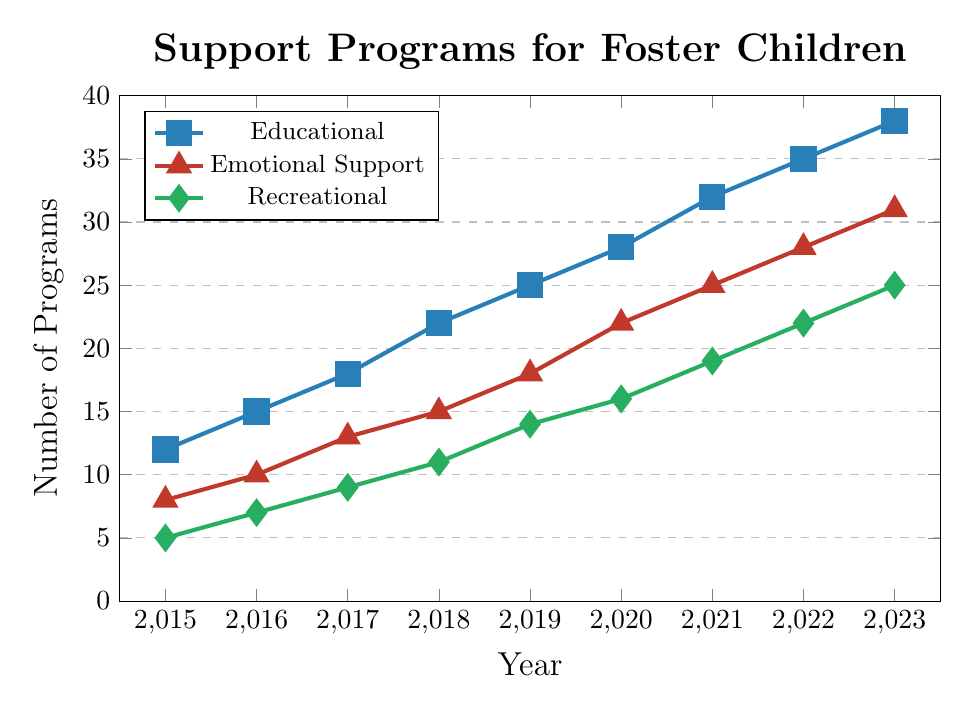What type of support programs had the highest increase in numbers from 2015 to 2023? Calculate the difference in the number of programs from 2015 to 2023 for each type: Educational (38-12=26), Emotional Support (31-8=23), and Recreational (25-5=20). The highest increase is in Educational programs.
Answer: Educational How many types of support programs had more than 20 programs in 2021? Check the number of programs for each type in 2021: Educational (32), Emotional Support (25), and Recreational (19). Only Educational and Emotional Support programs had more than 20 in 2021.
Answer: 2 Which year saw the greatest increase in the number of emotional support programs compared to the previous year? Calculate the yearly increases in emotional support programs: 2016-2015 (2), 2017-2016 (3), 2018-2017 (2), 2019-2018 (3), 2020-2019 (4), 2021-2020 (3), 2022-2021 (3), 2023-2022 (3). The greatest increase is from 2019 to 2020, with an increase of 4 programs.
Answer: 2020 What is the total number of recreational programs from 2015 to 2020? Sum the values for recreational programs from 2015 to 2020: 5 + 7 + 9 + 11 + 14 + 16 = 62.
Answer: 62 Which type of support program had the least number of new programs introduced in 2018? Check the number of programs introduced in 2018 for each type: Educational (22), Emotional Support (15), and Recreational (11). Recreational had the least number of new programs.
Answer: Recreational How many more educational programs were there than emotional support programs in 2023? Subtract the number of emotional support programs from educational programs in 2023: 38 - 31 = 7.
Answer: 7 Between which consecutive years did the number of recreational programs grow by 5 programs? Calculate the yearly differences for recreational programs: 2016-2015 (2), 2017-2016 (2), 2018-2017 (2), 2019-2018 (3), 2020-2019 (2), 2021-2020 (3), 2022-2021 (3), 2023-2022 (3). No year had an increase of 5 programs.
Answer: None 